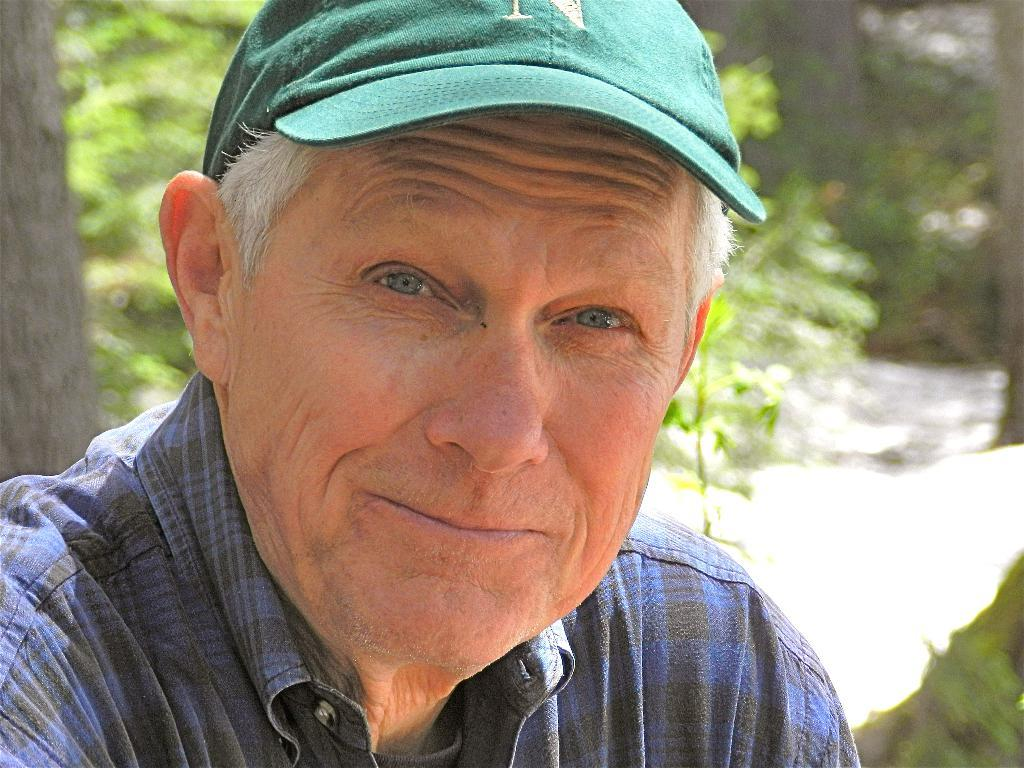What is the main subject in the foreground of the image? There is a person in the foreground of the image. What type of headwear is the person wearing? The person is wearing a cap. What type of flower is the person holding in the image? There is no flower present in the image; the person is only wearing a cap. 